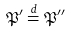Convert formula to latex. <formula><loc_0><loc_0><loc_500><loc_500>\mathfrak { P } ^ { \prime } \stackrel { d } { = } \mathfrak { P } ^ { \prime \prime }</formula> 